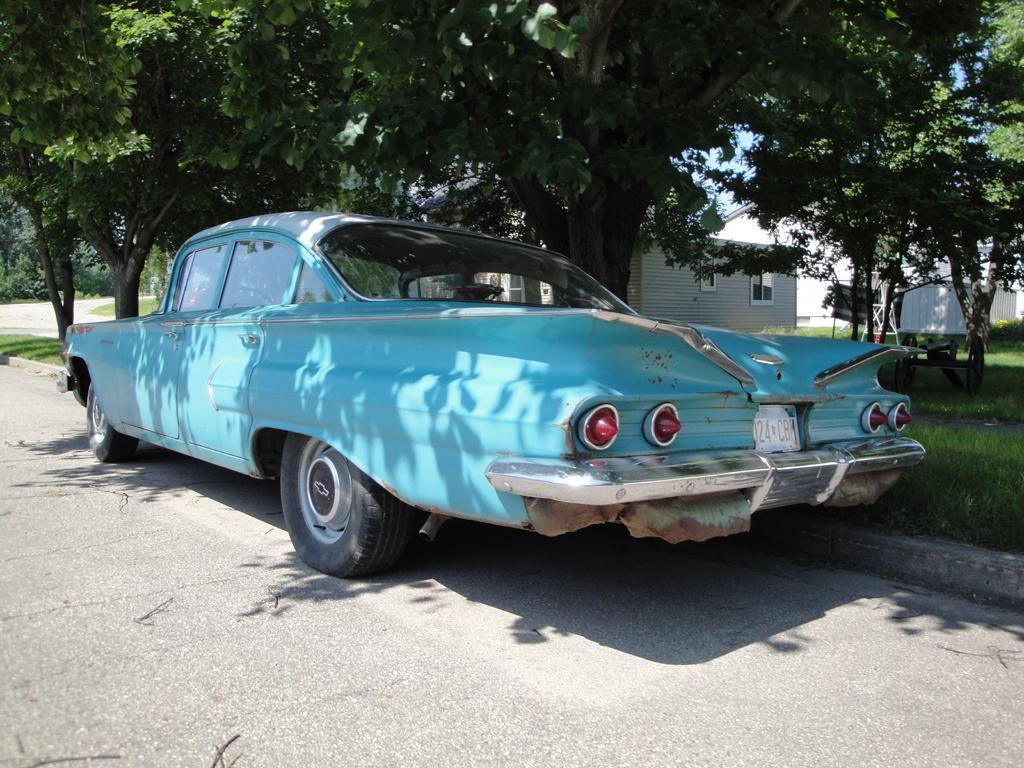How would you summarize this image in a sentence or two? In the center of the image there is a car on the road. In the background there are houses, trees and grass. 